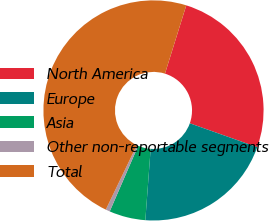Convert chart to OTSL. <chart><loc_0><loc_0><loc_500><loc_500><pie_chart><fcel>North America<fcel>Europe<fcel>Asia<fcel>Other non-reportable segments<fcel>Total<nl><fcel>25.61%<fcel>20.76%<fcel>5.33%<fcel>0.62%<fcel>47.68%<nl></chart> 